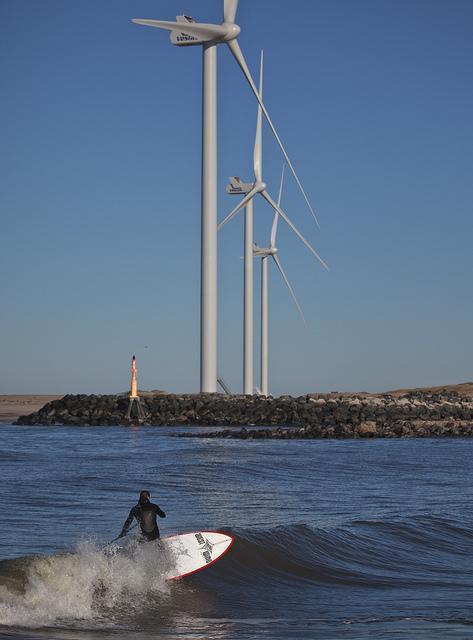How many people are standing on their surfboards?
Give a very brief answer. 1. 